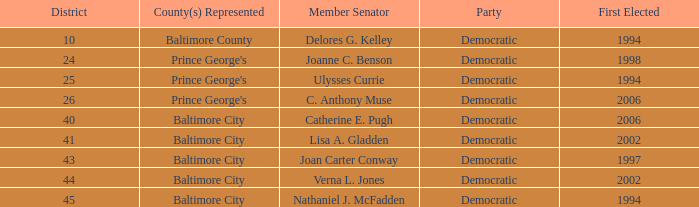Who was firest elected in 2002 in a district larger than 41? Verna L. Jones. 